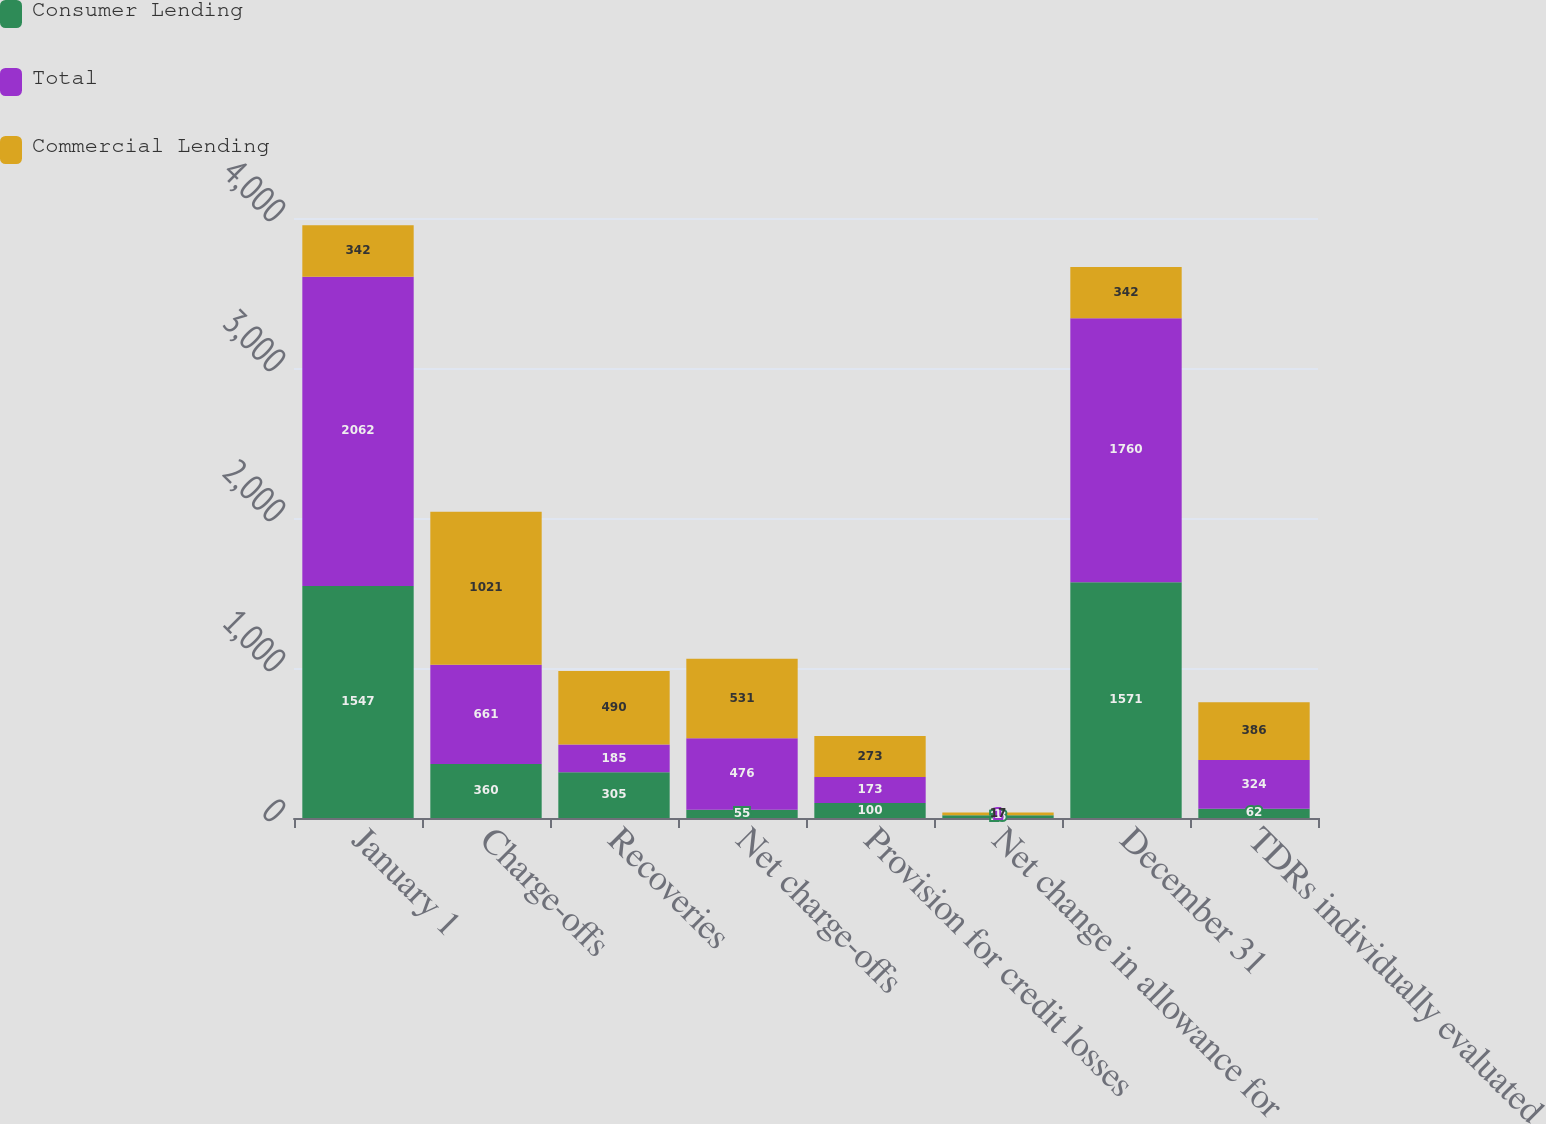Convert chart to OTSL. <chart><loc_0><loc_0><loc_500><loc_500><stacked_bar_chart><ecel><fcel>January 1<fcel>Charge-offs<fcel>Recoveries<fcel>Net charge-offs<fcel>Provision for credit losses<fcel>Net change in allowance for<fcel>December 31<fcel>TDRs individually evaluated<nl><fcel>Consumer Lending<fcel>1547<fcel>360<fcel>305<fcel>55<fcel>100<fcel>18<fcel>1571<fcel>62<nl><fcel>Total<fcel>2062<fcel>661<fcel>185<fcel>476<fcel>173<fcel>1<fcel>1760<fcel>324<nl><fcel>Commercial Lending<fcel>342<fcel>1021<fcel>490<fcel>531<fcel>273<fcel>17<fcel>342<fcel>386<nl></chart> 